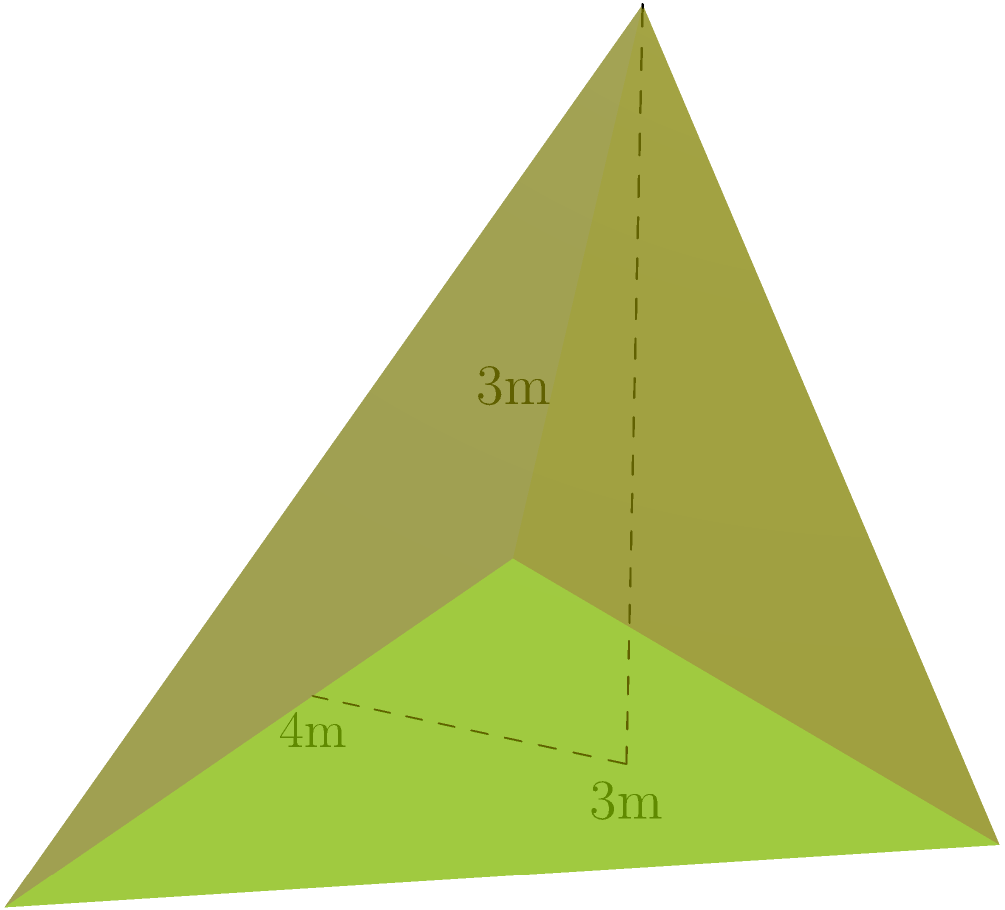In Zenica, a pyramid-shaped monument is being constructed to represent different architectural eras. The base of the monument is a triangle with sides measuring 4m, 3m, and 5m. The height of the pyramid is 3m. Calculate the total surface area of the monument, including the base. To find the total surface area, we need to calculate the area of the base and the areas of the three triangular faces, then sum them up.

Step 1: Calculate the area of the base triangle using Heron's formula.
Let $s$ be the semi-perimeter of the base triangle:
$s = \frac{4 + 3 + 5}{2} = 6$

Area of base = $\sqrt{s(s-a)(s-b)(s-c)}$
$= \sqrt{6(6-4)(6-3)(6-5)}$
$= \sqrt{6 \cdot 2 \cdot 3 \cdot 1}$
$= \sqrt{36} = 6$ m²

Step 2: Calculate the areas of the three triangular faces.
For each face, we need to find its height using the Pythagorean theorem:

$h^2 = 3^2 + (\text{half of base side})^2$

For the 4m side: $h_1 = \sqrt{3^2 + 2^2} = \sqrt{13}$ m
Area of face 1 = $\frac{1}{2} \cdot 4 \cdot \sqrt{13}$ m²

For the 3m side: $h_2 = \sqrt{3^2 + 1.5^2} = \sqrt{11.25}$ m
Area of face 2 = $\frac{1}{2} \cdot 3 \cdot \sqrt{11.25}$ m²

For the 5m side: $h_3 = \sqrt{3^2 + 2.5^2} = \sqrt{15.25}$ m
Area of face 3 = $\frac{1}{2} \cdot 5 \cdot \sqrt{15.25}$ m²

Step 3: Sum up all areas to get the total surface area.
Total surface area = Area of base + Area of face 1 + Area of face 2 + Area of face 3
$= 6 + 2\sqrt{13} + \frac{3}{2}\sqrt{11.25} + \frac{5}{2}\sqrt{15.25}$ m²
Answer: $6 + 2\sqrt{13} + \frac{3}{2}\sqrt{11.25} + \frac{5}{2}\sqrt{15.25}$ m² 